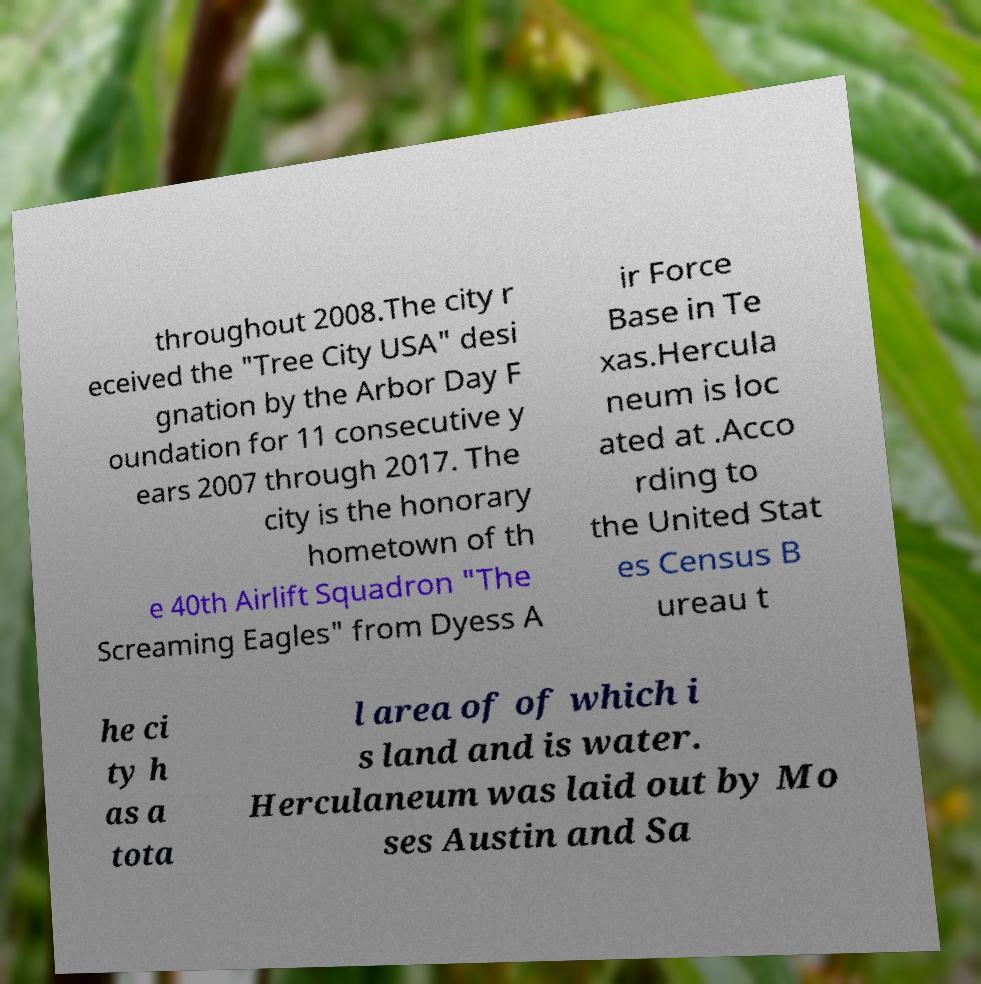Please read and relay the text visible in this image. What does it say? throughout 2008.The city r eceived the "Tree City USA" desi gnation by the Arbor Day F oundation for 11 consecutive y ears 2007 through 2017. The city is the honorary hometown of th e 40th Airlift Squadron "The Screaming Eagles" from Dyess A ir Force Base in Te xas.Hercula neum is loc ated at .Acco rding to the United Stat es Census B ureau t he ci ty h as a tota l area of of which i s land and is water. Herculaneum was laid out by Mo ses Austin and Sa 